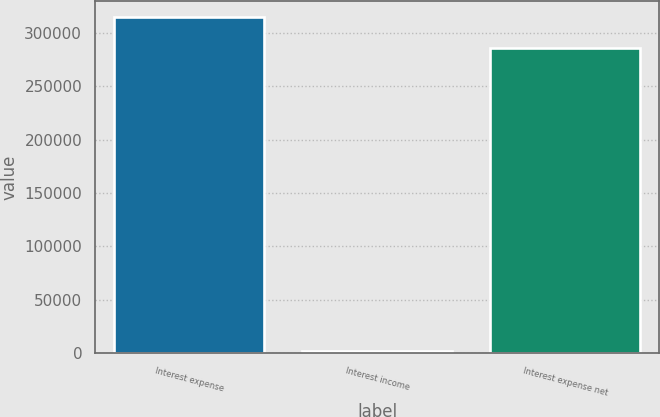Convert chart to OTSL. <chart><loc_0><loc_0><loc_500><loc_500><bar_chart><fcel>Interest expense<fcel>Interest income<fcel>Interest expense net<nl><fcel>314509<fcel>2004<fcel>285917<nl></chart> 